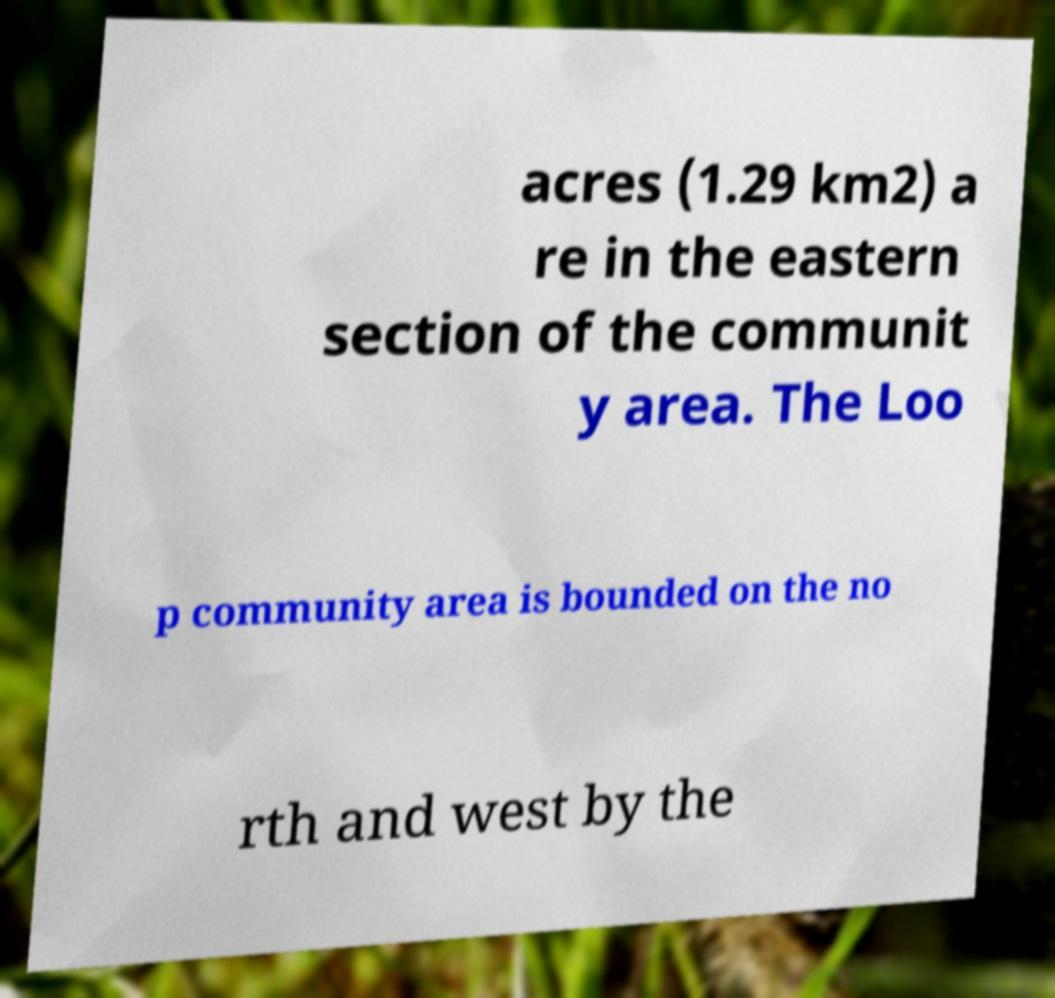For documentation purposes, I need the text within this image transcribed. Could you provide that? acres (1.29 km2) a re in the eastern section of the communit y area. The Loo p community area is bounded on the no rth and west by the 